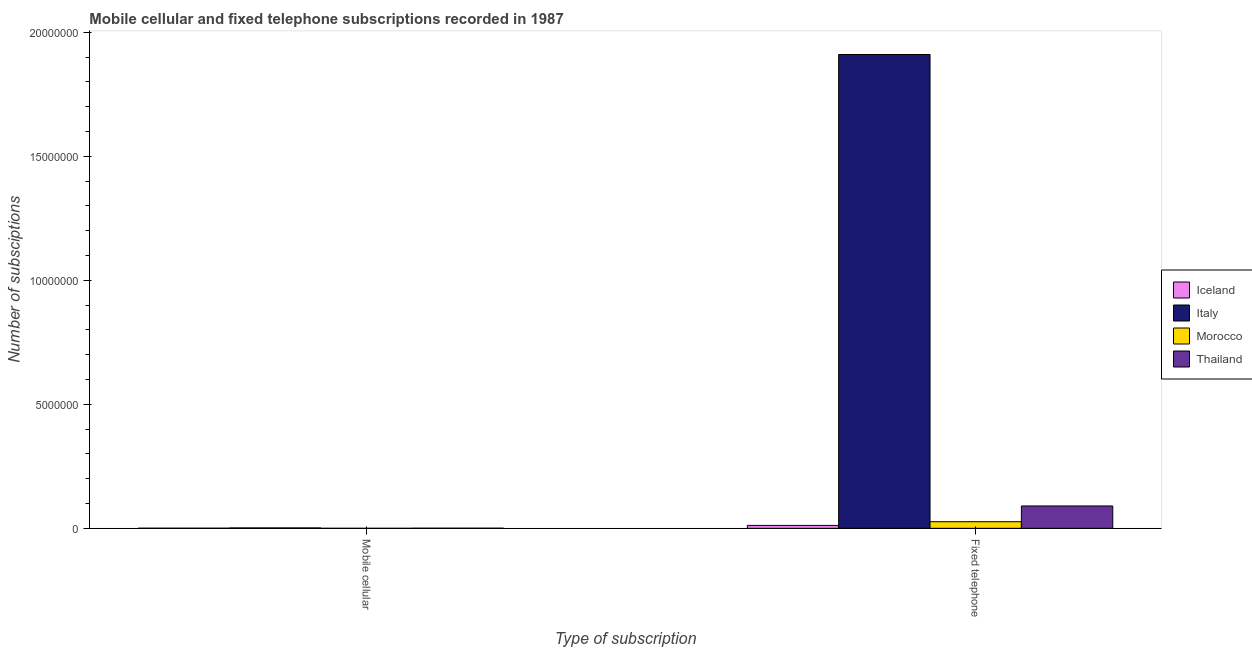How many different coloured bars are there?
Keep it short and to the point. 4. Are the number of bars per tick equal to the number of legend labels?
Give a very brief answer. Yes. How many bars are there on the 1st tick from the left?
Your answer should be compact. 4. How many bars are there on the 1st tick from the right?
Offer a terse response. 4. What is the label of the 1st group of bars from the left?
Offer a terse response. Mobile cellular. What is the number of fixed telephone subscriptions in Iceland?
Keep it short and to the point. 1.17e+05. Across all countries, what is the maximum number of mobile cellular subscriptions?
Offer a very short reply. 1.65e+04. Across all countries, what is the minimum number of mobile cellular subscriptions?
Your response must be concise. 60. In which country was the number of mobile cellular subscriptions minimum?
Your answer should be very brief. Morocco. What is the total number of fixed telephone subscriptions in the graph?
Offer a very short reply. 2.04e+07. What is the difference between the number of fixed telephone subscriptions in Morocco and that in Thailand?
Provide a succinct answer. -6.35e+05. What is the difference between the number of fixed telephone subscriptions in Thailand and the number of mobile cellular subscriptions in Iceland?
Keep it short and to the point. 8.97e+05. What is the average number of mobile cellular subscriptions per country?
Your answer should be compact. 6871. What is the difference between the number of mobile cellular subscriptions and number of fixed telephone subscriptions in Morocco?
Provide a succinct answer. -2.66e+05. What is the ratio of the number of fixed telephone subscriptions in Thailand to that in Morocco?
Keep it short and to the point. 3.39. What does the 4th bar from the left in Mobile cellular represents?
Keep it short and to the point. Thailand. What does the 1st bar from the right in Mobile cellular represents?
Offer a terse response. Thailand. Are all the bars in the graph horizontal?
Offer a very short reply. No. What is the difference between two consecutive major ticks on the Y-axis?
Offer a very short reply. 5.00e+06. Are the values on the major ticks of Y-axis written in scientific E-notation?
Offer a very short reply. No. Where does the legend appear in the graph?
Keep it short and to the point. Center right. How many legend labels are there?
Your response must be concise. 4. How are the legend labels stacked?
Give a very brief answer. Vertical. What is the title of the graph?
Offer a terse response. Mobile cellular and fixed telephone subscriptions recorded in 1987. What is the label or title of the X-axis?
Give a very brief answer. Type of subscription. What is the label or title of the Y-axis?
Provide a short and direct response. Number of subsciptions. What is the Number of subsciptions in Iceland in Mobile cellular?
Your response must be concise. 5008. What is the Number of subsciptions of Italy in Mobile cellular?
Give a very brief answer. 1.65e+04. What is the Number of subsciptions in Thailand in Mobile cellular?
Ensure brevity in your answer.  5882. What is the Number of subsciptions in Iceland in Fixed telephone?
Provide a succinct answer. 1.17e+05. What is the Number of subsciptions in Italy in Fixed telephone?
Your response must be concise. 1.91e+07. What is the Number of subsciptions of Morocco in Fixed telephone?
Your response must be concise. 2.66e+05. What is the Number of subsciptions of Thailand in Fixed telephone?
Give a very brief answer. 9.02e+05. Across all Type of subscription, what is the maximum Number of subsciptions in Iceland?
Your answer should be very brief. 1.17e+05. Across all Type of subscription, what is the maximum Number of subsciptions in Italy?
Give a very brief answer. 1.91e+07. Across all Type of subscription, what is the maximum Number of subsciptions of Morocco?
Provide a short and direct response. 2.66e+05. Across all Type of subscription, what is the maximum Number of subsciptions in Thailand?
Your answer should be compact. 9.02e+05. Across all Type of subscription, what is the minimum Number of subsciptions of Iceland?
Keep it short and to the point. 5008. Across all Type of subscription, what is the minimum Number of subsciptions of Italy?
Make the answer very short. 1.65e+04. Across all Type of subscription, what is the minimum Number of subsciptions in Morocco?
Give a very brief answer. 60. Across all Type of subscription, what is the minimum Number of subsciptions in Thailand?
Ensure brevity in your answer.  5882. What is the total Number of subsciptions of Iceland in the graph?
Give a very brief answer. 1.22e+05. What is the total Number of subsciptions in Italy in the graph?
Offer a very short reply. 1.91e+07. What is the total Number of subsciptions of Morocco in the graph?
Make the answer very short. 2.66e+05. What is the total Number of subsciptions in Thailand in the graph?
Give a very brief answer. 9.08e+05. What is the difference between the Number of subsciptions of Iceland in Mobile cellular and that in Fixed telephone?
Keep it short and to the point. -1.12e+05. What is the difference between the Number of subsciptions in Italy in Mobile cellular and that in Fixed telephone?
Your answer should be very brief. -1.91e+07. What is the difference between the Number of subsciptions of Morocco in Mobile cellular and that in Fixed telephone?
Your answer should be very brief. -2.66e+05. What is the difference between the Number of subsciptions of Thailand in Mobile cellular and that in Fixed telephone?
Provide a succinct answer. -8.96e+05. What is the difference between the Number of subsciptions of Iceland in Mobile cellular and the Number of subsciptions of Italy in Fixed telephone?
Offer a terse response. -1.91e+07. What is the difference between the Number of subsciptions in Iceland in Mobile cellular and the Number of subsciptions in Morocco in Fixed telephone?
Provide a succinct answer. -2.61e+05. What is the difference between the Number of subsciptions in Iceland in Mobile cellular and the Number of subsciptions in Thailand in Fixed telephone?
Ensure brevity in your answer.  -8.97e+05. What is the difference between the Number of subsciptions in Italy in Mobile cellular and the Number of subsciptions in Morocco in Fixed telephone?
Make the answer very short. -2.50e+05. What is the difference between the Number of subsciptions of Italy in Mobile cellular and the Number of subsciptions of Thailand in Fixed telephone?
Give a very brief answer. -8.85e+05. What is the difference between the Number of subsciptions in Morocco in Mobile cellular and the Number of subsciptions in Thailand in Fixed telephone?
Your answer should be very brief. -9.02e+05. What is the average Number of subsciptions of Iceland per Type of subscription?
Your answer should be very brief. 6.12e+04. What is the average Number of subsciptions in Italy per Type of subscription?
Your response must be concise. 9.56e+06. What is the average Number of subsciptions in Morocco per Type of subscription?
Your answer should be compact. 1.33e+05. What is the average Number of subsciptions of Thailand per Type of subscription?
Offer a terse response. 4.54e+05. What is the difference between the Number of subsciptions of Iceland and Number of subsciptions of Italy in Mobile cellular?
Your answer should be very brief. -1.15e+04. What is the difference between the Number of subsciptions of Iceland and Number of subsciptions of Morocco in Mobile cellular?
Offer a terse response. 4948. What is the difference between the Number of subsciptions of Iceland and Number of subsciptions of Thailand in Mobile cellular?
Provide a succinct answer. -874. What is the difference between the Number of subsciptions in Italy and Number of subsciptions in Morocco in Mobile cellular?
Provide a succinct answer. 1.65e+04. What is the difference between the Number of subsciptions in Italy and Number of subsciptions in Thailand in Mobile cellular?
Your answer should be compact. 1.07e+04. What is the difference between the Number of subsciptions of Morocco and Number of subsciptions of Thailand in Mobile cellular?
Give a very brief answer. -5822. What is the difference between the Number of subsciptions of Iceland and Number of subsciptions of Italy in Fixed telephone?
Ensure brevity in your answer.  -1.90e+07. What is the difference between the Number of subsciptions in Iceland and Number of subsciptions in Morocco in Fixed telephone?
Ensure brevity in your answer.  -1.49e+05. What is the difference between the Number of subsciptions in Iceland and Number of subsciptions in Thailand in Fixed telephone?
Your response must be concise. -7.84e+05. What is the difference between the Number of subsciptions of Italy and Number of subsciptions of Morocco in Fixed telephone?
Give a very brief answer. 1.88e+07. What is the difference between the Number of subsciptions of Italy and Number of subsciptions of Thailand in Fixed telephone?
Keep it short and to the point. 1.82e+07. What is the difference between the Number of subsciptions of Morocco and Number of subsciptions of Thailand in Fixed telephone?
Your answer should be very brief. -6.35e+05. What is the ratio of the Number of subsciptions in Iceland in Mobile cellular to that in Fixed telephone?
Make the answer very short. 0.04. What is the ratio of the Number of subsciptions in Italy in Mobile cellular to that in Fixed telephone?
Your response must be concise. 0. What is the ratio of the Number of subsciptions in Thailand in Mobile cellular to that in Fixed telephone?
Your answer should be compact. 0.01. What is the difference between the highest and the second highest Number of subsciptions of Iceland?
Your response must be concise. 1.12e+05. What is the difference between the highest and the second highest Number of subsciptions of Italy?
Offer a very short reply. 1.91e+07. What is the difference between the highest and the second highest Number of subsciptions of Morocco?
Make the answer very short. 2.66e+05. What is the difference between the highest and the second highest Number of subsciptions in Thailand?
Your answer should be compact. 8.96e+05. What is the difference between the highest and the lowest Number of subsciptions of Iceland?
Offer a very short reply. 1.12e+05. What is the difference between the highest and the lowest Number of subsciptions in Italy?
Offer a very short reply. 1.91e+07. What is the difference between the highest and the lowest Number of subsciptions of Morocco?
Your response must be concise. 2.66e+05. What is the difference between the highest and the lowest Number of subsciptions in Thailand?
Make the answer very short. 8.96e+05. 